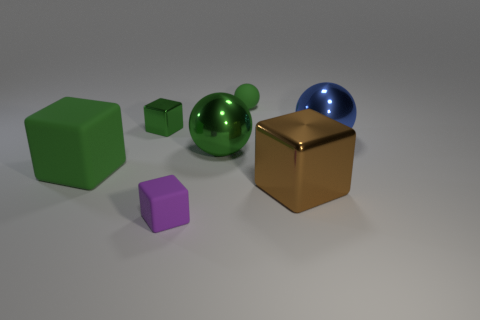Subtract 1 cubes. How many cubes are left? 3 Add 3 brown shiny blocks. How many objects exist? 10 Subtract all balls. How many objects are left? 4 Subtract all tiny red cylinders. Subtract all tiny green cubes. How many objects are left? 6 Add 4 big things. How many big things are left? 8 Add 7 large blue things. How many large blue things exist? 8 Subtract 0 cyan cylinders. How many objects are left? 7 